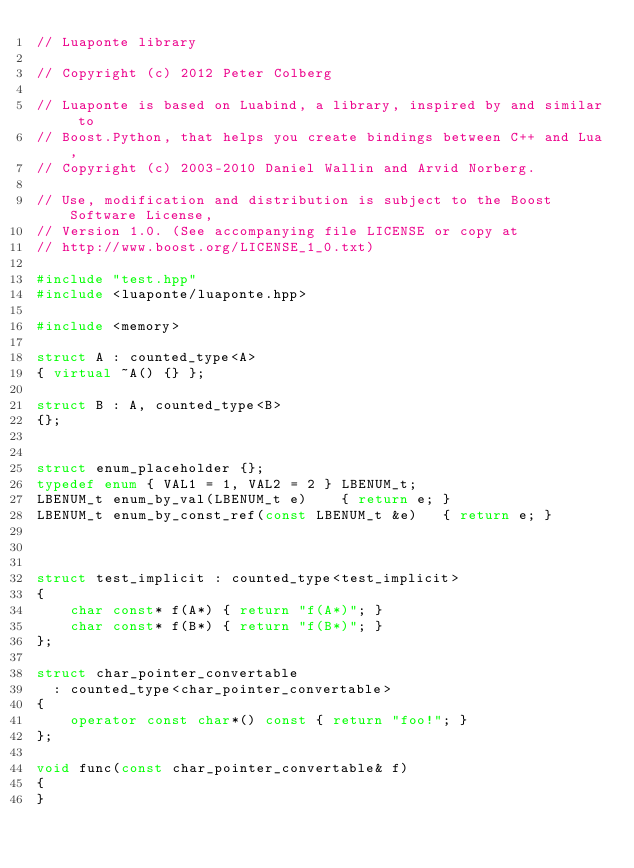Convert code to text. <code><loc_0><loc_0><loc_500><loc_500><_C++_>// Luaponte library

// Copyright (c) 2012 Peter Colberg

// Luaponte is based on Luabind, a library, inspired by and similar to
// Boost.Python, that helps you create bindings between C++ and Lua,
// Copyright (c) 2003-2010 Daniel Wallin and Arvid Norberg.

// Use, modification and distribution is subject to the Boost Software License,
// Version 1.0. (See accompanying file LICENSE or copy at
// http://www.boost.org/LICENSE_1_0.txt)

#include "test.hpp"
#include <luaponte/luaponte.hpp>

#include <memory>

struct A : counted_type<A> 
{ virtual ~A() {} };

struct B : A, counted_type<B>  
{};


struct enum_placeholder {};
typedef enum { VAL1 = 1, VAL2 = 2 } LBENUM_t;
LBENUM_t enum_by_val(LBENUM_t e)    { return e; }
LBENUM_t enum_by_const_ref(const LBENUM_t &e)   { return e; }



struct test_implicit : counted_type<test_implicit>
{
    char const* f(A*) { return "f(A*)"; }
    char const* f(B*) { return "f(B*)"; }
};

struct char_pointer_convertable
  : counted_type<char_pointer_convertable>
{
    operator const char*() const { return "foo!"; }
};

void func(const char_pointer_convertable& f)
{
}
</code> 